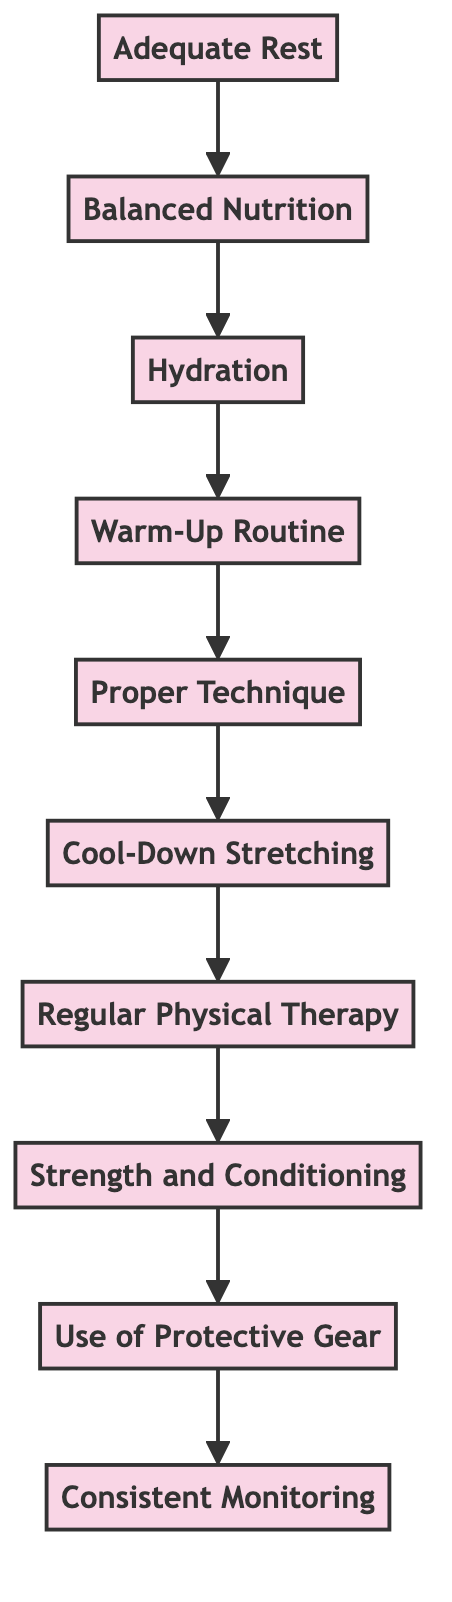What is the first step in the flow? The first step in the flow, which is at the bottom of the diagram, is "Consistent Monitoring." This is the last node that you follow up the flow to reach the top.
Answer: Consistent Monitoring How many nodes are in the diagram? By counting the individual elements represented in the flowchart, I find there are ten nodes listed. Each of these nodes represents a unique aspect of injury prevention and recovery strategies.
Answer: 10 Which node comes after Cool-Down Stretching? After "Cool-Down Stretching," the flow leads up to "Regular Physical Therapy," indicating that following cool-down, one should engage in physical therapy sessions as the next step.
Answer: Regular Physical Therapy What links Balanced Nutrition and Hydration? "Balanced Nutrition" leads to "Hydration," meaning that proper nutrition is a precursor to maintaining hydration, which supports overall muscle function and recovery processes.
Answer: Hydration Which two nodes are connected directly to Proper Technique? "Proper Technique" is connected directly to "Warm-Up Routine" as well as "Cool-Down Stretching," indicating that these two are essential components that support safe lifting practices.
Answer: Warm-Up Routine, Cool-Down Stretching What is the final step in the flow? The final step in this flow, which is the topmost node, is "Consistent Monitoring." This represents the overarching strategy that integrates all previous steps to ensure a comprehensive approach to injury prevention and recovery.
Answer: Consistent Monitoring How does Adequate Rest relate to Balanced Nutrition? "Adequate Rest" leads to "Balanced Nutrition," suggesting that sufficient rest is essential for the body before engaging in nutrition strategies that support recovery. This creates a sequential relationship where one enhances the effectiveness of the other.
Answer: Balanced Nutrition Which node emphasizes the use of equipment? The "Use of Protective Gear" node emphasizes the importance of using appropriate equipment during heavy lifts, showcasing its role in injury prevention along the flow.
Answer: Use of Protective Gear How many edges are there in total? By examining the connections between nodes, there are nine edges shown in the flowchart indicating the links between each step in the diagram.
Answer: 9 